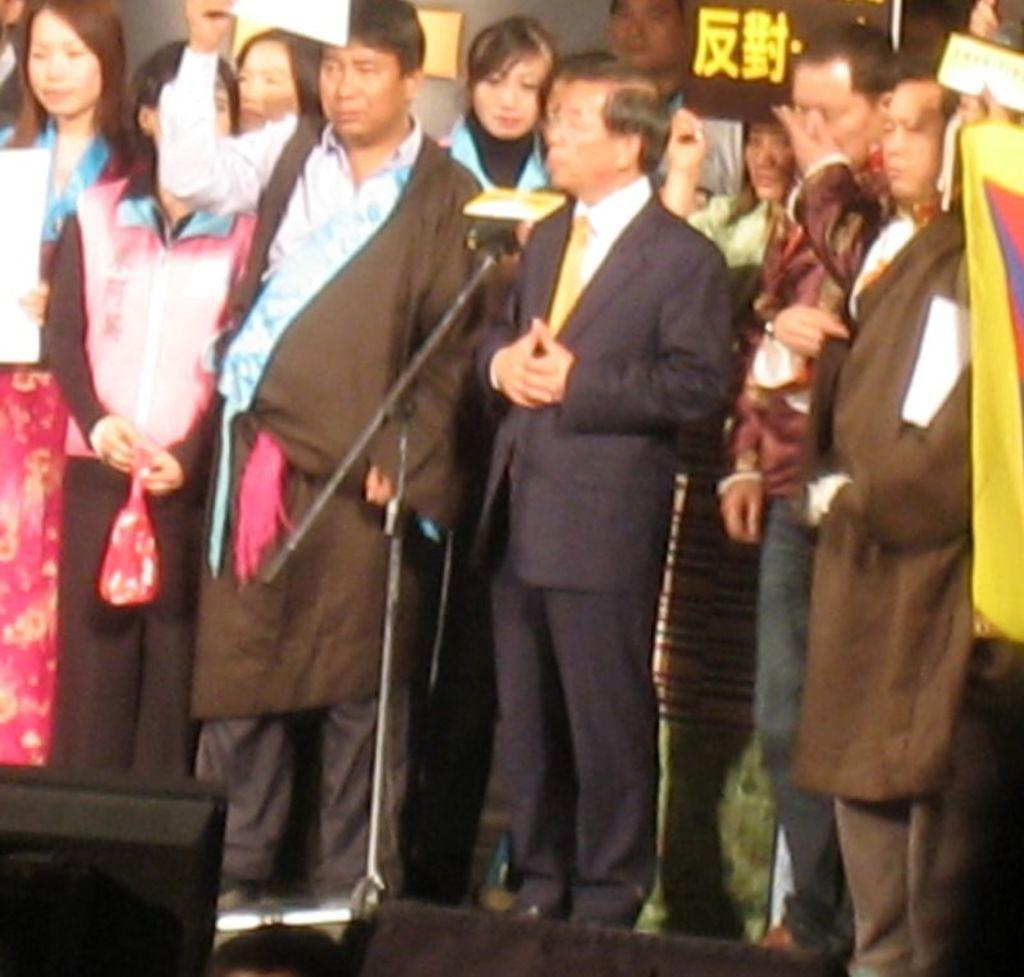What type of equipment can be seen in the image? There are speakers and a microphone with a microphone stand in the image. Where are the people in the image located? The people are on a stage in the image. What are the people on the stage holding? The people on the stage are holding a flag. Can you describe any other objects in the image? There are some objects in the image, but their specific details are not mentioned in the provided facts. What type of plastic is used to make the shop in the image? There is no shop present in the image, so it is not possible to determine the type of plastic used. 